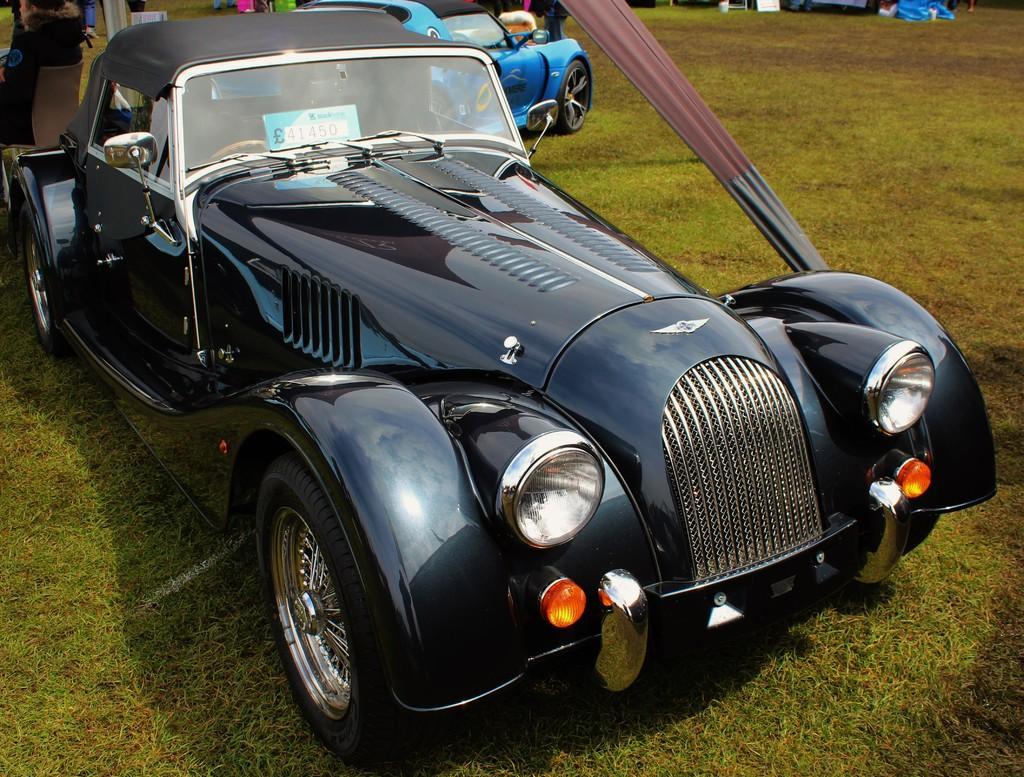Please provide a concise description of this image. In this image we can see the cars. And at the bottom we can see the grass. And some other cars can be seen. 